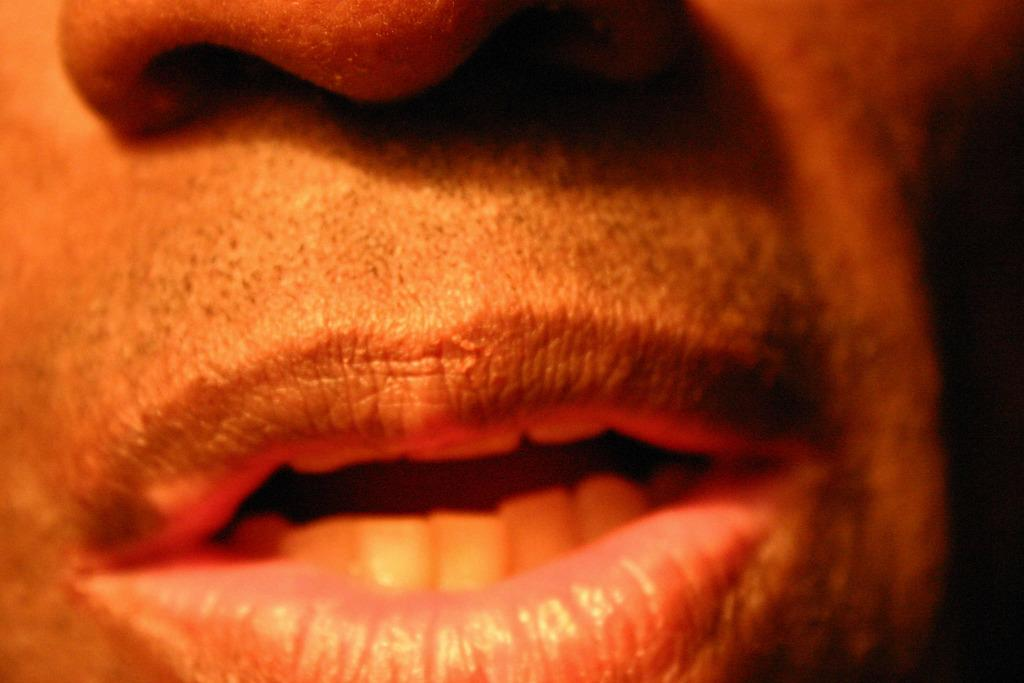What facial feature can be seen in the image? There is a mouth and a nose in the image. What can be found inside the mouth in the image? Teeth are visible in the image. What type of rice is being cooked by the women on their voyage in the image? There is no reference to rice, women, or a voyage in the image; it only features a mouth and a nose with visible teeth. 